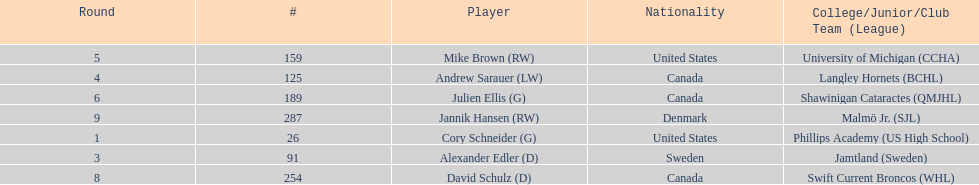How many canadian players are listed? 3. 